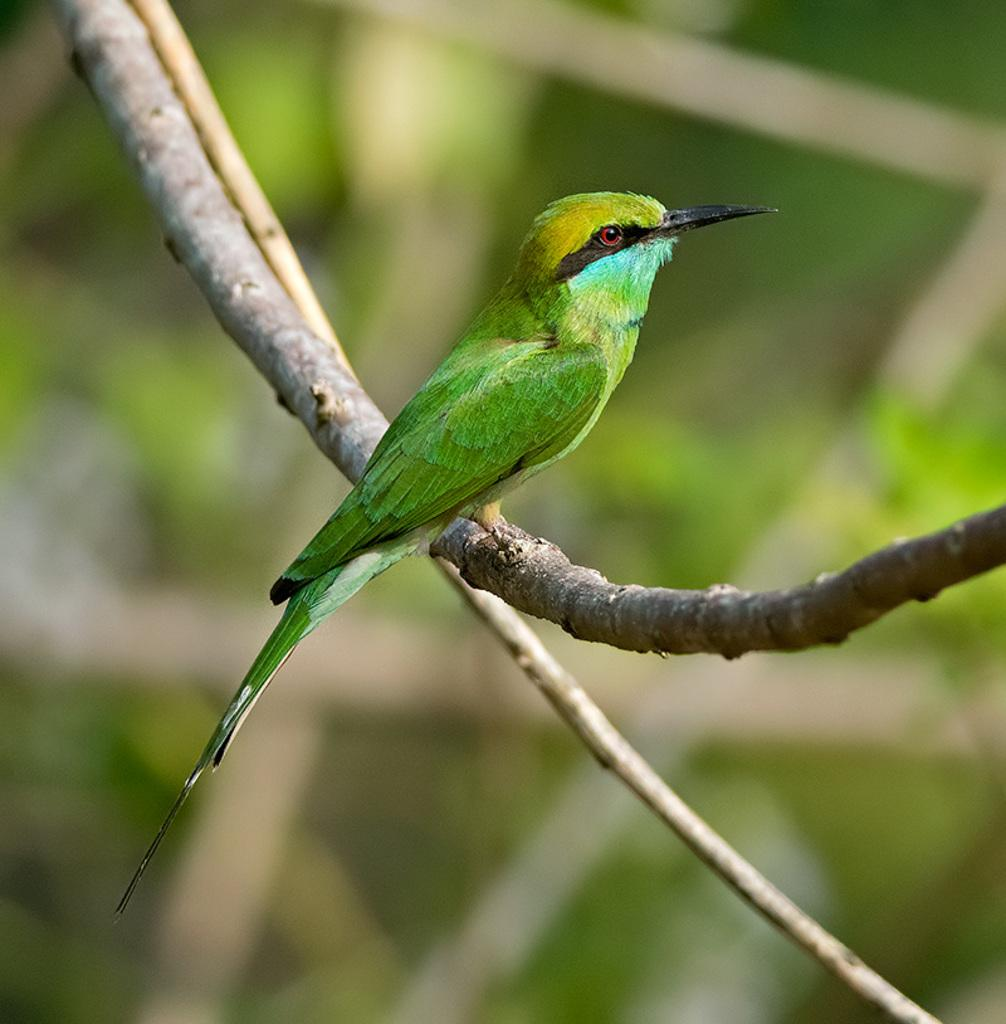What type of animal is in the image? There is a bird in the image. Where is the bird located? The bird is on a stem in the image. What other object can be seen in the image? There is a stick in the image. Can you describe the background of the image? The background of the image is blurry. What advice does the bird give to the doll at the playground in the image? There is no doll or playground present in the image, and the bird does not give any advice. 